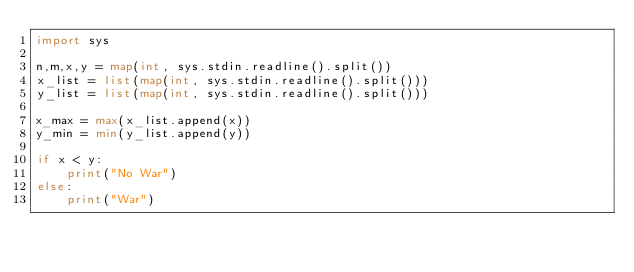Convert code to text. <code><loc_0><loc_0><loc_500><loc_500><_Python_>import sys

n,m,x,y = map(int, sys.stdin.readline().split())
x_list = list(map(int, sys.stdin.readline().split()))
y_list = list(map(int, sys.stdin.readline().split()))

x_max = max(x_list.append(x))
y_min = min(y_list.append(y))

if x < y:
    print("No War")
else:
    print("War")</code> 